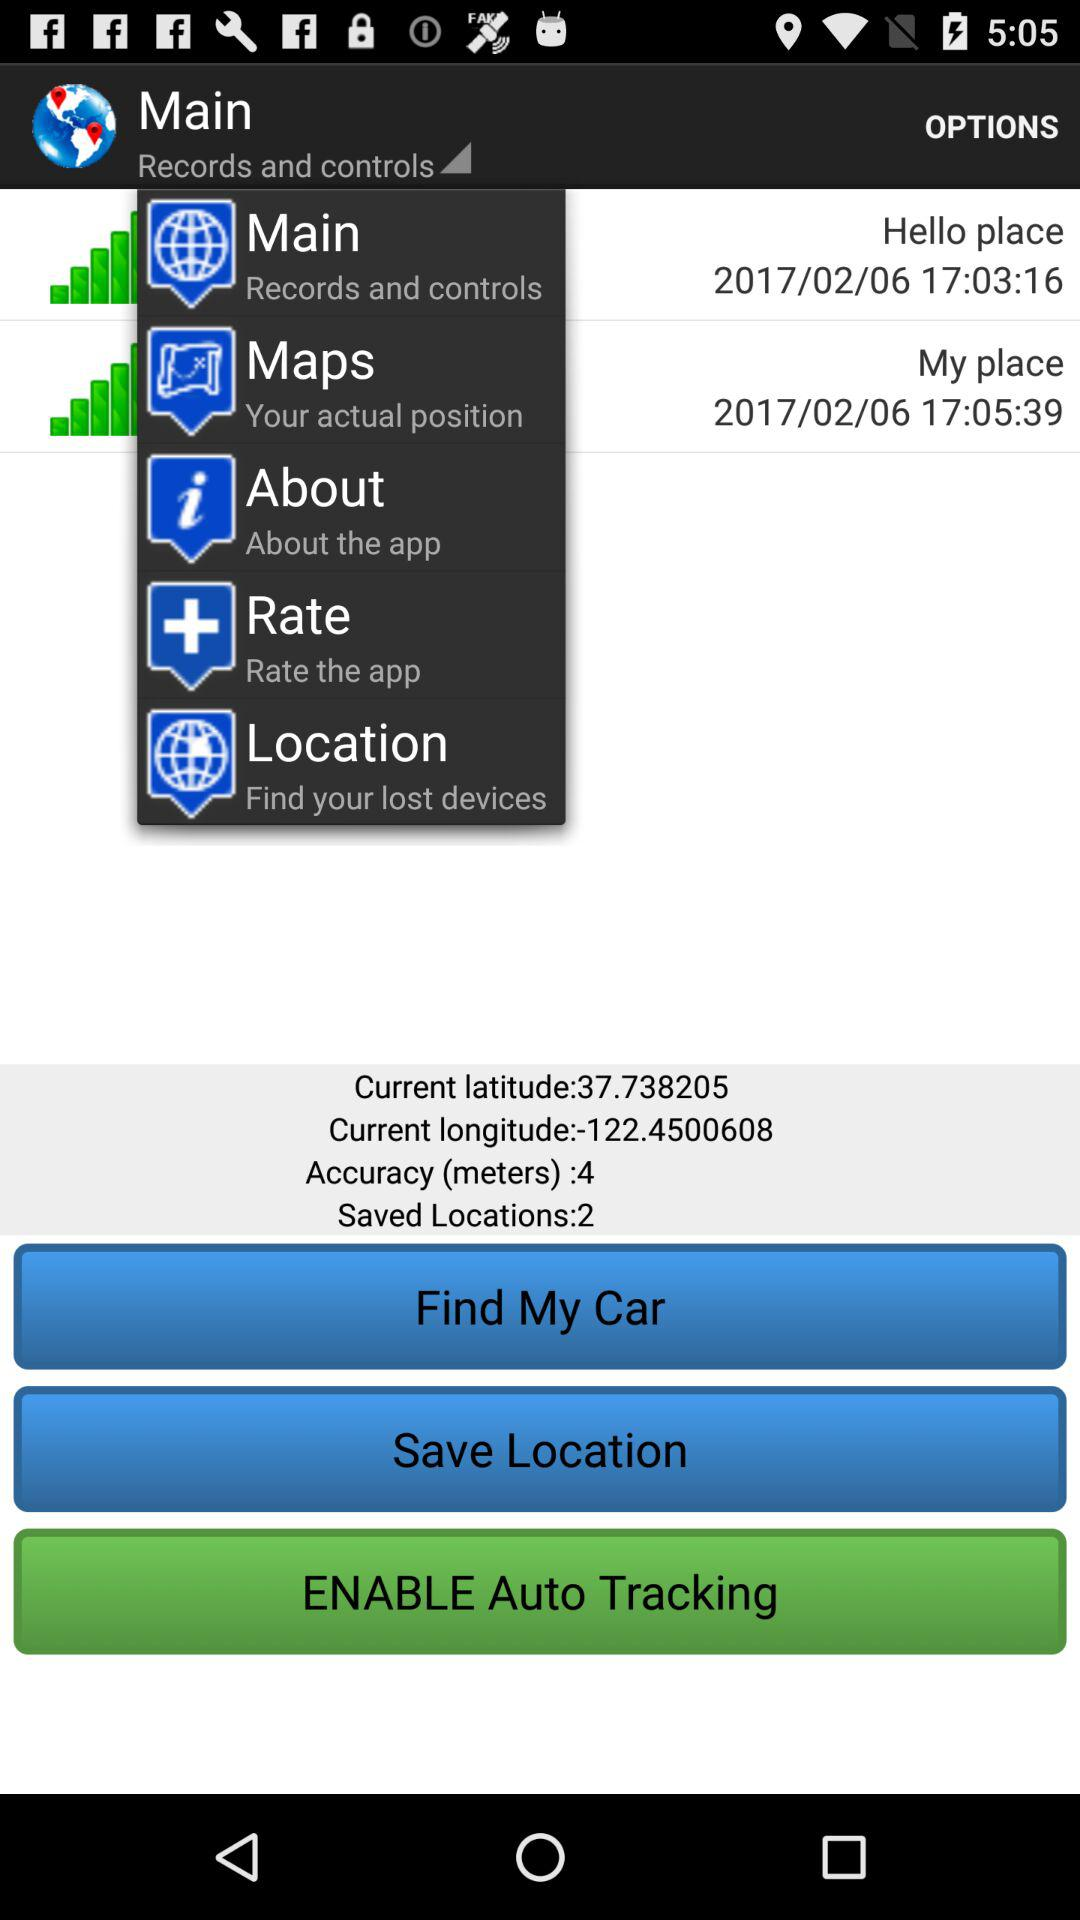What is the current latitude? The current latitude is 37.738205. 